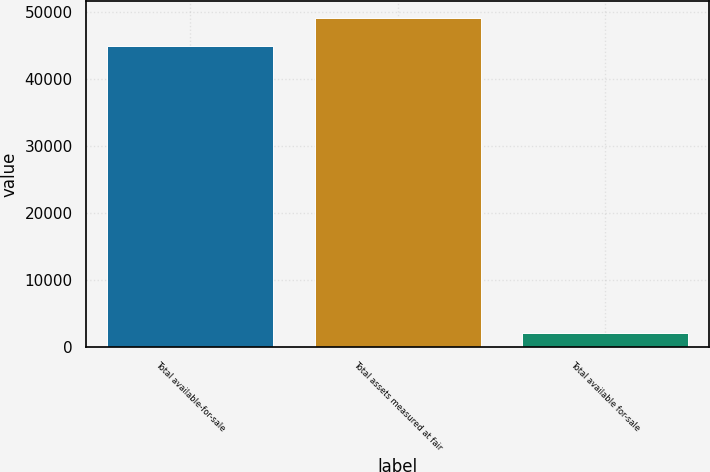Convert chart to OTSL. <chart><loc_0><loc_0><loc_500><loc_500><bar_chart><fcel>Total available-for-sale<fcel>Total assets measured at fair<fcel>Total available for-sale<nl><fcel>44897<fcel>49171.7<fcel>2150<nl></chart> 